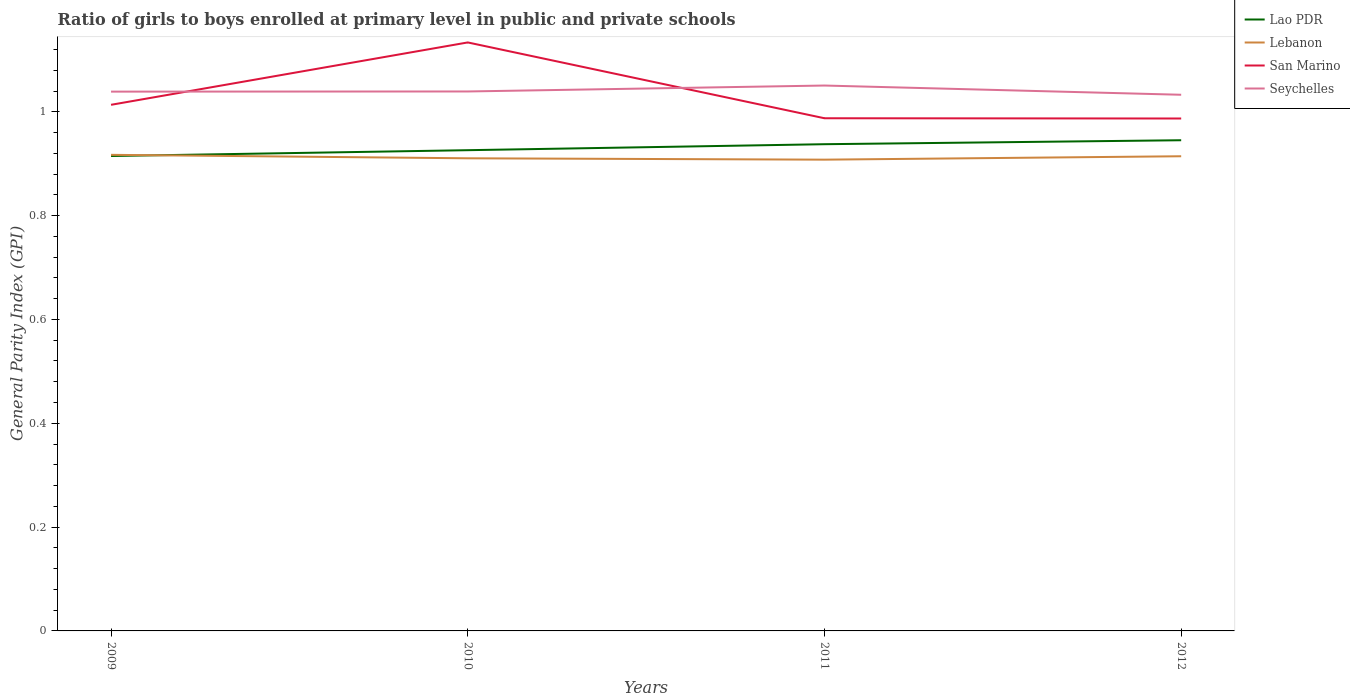Does the line corresponding to San Marino intersect with the line corresponding to Lebanon?
Offer a terse response. No. Is the number of lines equal to the number of legend labels?
Make the answer very short. Yes. Across all years, what is the maximum general parity index in San Marino?
Offer a very short reply. 0.99. In which year was the general parity index in Lao PDR maximum?
Offer a very short reply. 2009. What is the total general parity index in Lao PDR in the graph?
Keep it short and to the point. -0.01. What is the difference between the highest and the second highest general parity index in Lao PDR?
Offer a terse response. 0.03. What is the difference between the highest and the lowest general parity index in Lao PDR?
Your answer should be compact. 2. Does the graph contain any zero values?
Keep it short and to the point. No. Where does the legend appear in the graph?
Your answer should be compact. Top right. What is the title of the graph?
Provide a short and direct response. Ratio of girls to boys enrolled at primary level in public and private schools. What is the label or title of the Y-axis?
Keep it short and to the point. General Parity Index (GPI). What is the General Parity Index (GPI) of Lao PDR in 2009?
Make the answer very short. 0.91. What is the General Parity Index (GPI) of Lebanon in 2009?
Make the answer very short. 0.92. What is the General Parity Index (GPI) in San Marino in 2009?
Provide a short and direct response. 1.01. What is the General Parity Index (GPI) of Seychelles in 2009?
Give a very brief answer. 1.04. What is the General Parity Index (GPI) of Lao PDR in 2010?
Ensure brevity in your answer.  0.93. What is the General Parity Index (GPI) in Lebanon in 2010?
Offer a very short reply. 0.91. What is the General Parity Index (GPI) in San Marino in 2010?
Make the answer very short. 1.13. What is the General Parity Index (GPI) of Seychelles in 2010?
Your answer should be compact. 1.04. What is the General Parity Index (GPI) in Lao PDR in 2011?
Your answer should be very brief. 0.94. What is the General Parity Index (GPI) in Lebanon in 2011?
Provide a succinct answer. 0.91. What is the General Parity Index (GPI) in San Marino in 2011?
Provide a short and direct response. 0.99. What is the General Parity Index (GPI) in Seychelles in 2011?
Ensure brevity in your answer.  1.05. What is the General Parity Index (GPI) of Lao PDR in 2012?
Your response must be concise. 0.95. What is the General Parity Index (GPI) of Lebanon in 2012?
Offer a terse response. 0.91. What is the General Parity Index (GPI) in San Marino in 2012?
Provide a succinct answer. 0.99. What is the General Parity Index (GPI) of Seychelles in 2012?
Make the answer very short. 1.03. Across all years, what is the maximum General Parity Index (GPI) in Lao PDR?
Your answer should be compact. 0.95. Across all years, what is the maximum General Parity Index (GPI) in Lebanon?
Your response must be concise. 0.92. Across all years, what is the maximum General Parity Index (GPI) of San Marino?
Give a very brief answer. 1.13. Across all years, what is the maximum General Parity Index (GPI) in Seychelles?
Your answer should be very brief. 1.05. Across all years, what is the minimum General Parity Index (GPI) of Lao PDR?
Keep it short and to the point. 0.91. Across all years, what is the minimum General Parity Index (GPI) of Lebanon?
Offer a very short reply. 0.91. Across all years, what is the minimum General Parity Index (GPI) of San Marino?
Your answer should be compact. 0.99. Across all years, what is the minimum General Parity Index (GPI) in Seychelles?
Offer a terse response. 1.03. What is the total General Parity Index (GPI) of Lao PDR in the graph?
Keep it short and to the point. 3.72. What is the total General Parity Index (GPI) of Lebanon in the graph?
Keep it short and to the point. 3.65. What is the total General Parity Index (GPI) in San Marino in the graph?
Your answer should be compact. 4.12. What is the total General Parity Index (GPI) in Seychelles in the graph?
Your response must be concise. 4.16. What is the difference between the General Parity Index (GPI) of Lao PDR in 2009 and that in 2010?
Your answer should be very brief. -0.01. What is the difference between the General Parity Index (GPI) in Lebanon in 2009 and that in 2010?
Your answer should be very brief. 0.01. What is the difference between the General Parity Index (GPI) of San Marino in 2009 and that in 2010?
Offer a terse response. -0.12. What is the difference between the General Parity Index (GPI) of Seychelles in 2009 and that in 2010?
Give a very brief answer. -0. What is the difference between the General Parity Index (GPI) of Lao PDR in 2009 and that in 2011?
Your response must be concise. -0.02. What is the difference between the General Parity Index (GPI) of Lebanon in 2009 and that in 2011?
Ensure brevity in your answer.  0.01. What is the difference between the General Parity Index (GPI) in San Marino in 2009 and that in 2011?
Ensure brevity in your answer.  0.03. What is the difference between the General Parity Index (GPI) in Seychelles in 2009 and that in 2011?
Your answer should be very brief. -0.01. What is the difference between the General Parity Index (GPI) in Lao PDR in 2009 and that in 2012?
Keep it short and to the point. -0.03. What is the difference between the General Parity Index (GPI) in Lebanon in 2009 and that in 2012?
Ensure brevity in your answer.  0. What is the difference between the General Parity Index (GPI) in San Marino in 2009 and that in 2012?
Provide a short and direct response. 0.03. What is the difference between the General Parity Index (GPI) in Seychelles in 2009 and that in 2012?
Provide a succinct answer. 0.01. What is the difference between the General Parity Index (GPI) of Lao PDR in 2010 and that in 2011?
Keep it short and to the point. -0.01. What is the difference between the General Parity Index (GPI) of Lebanon in 2010 and that in 2011?
Ensure brevity in your answer.  0. What is the difference between the General Parity Index (GPI) of San Marino in 2010 and that in 2011?
Offer a terse response. 0.15. What is the difference between the General Parity Index (GPI) in Seychelles in 2010 and that in 2011?
Offer a very short reply. -0.01. What is the difference between the General Parity Index (GPI) of Lao PDR in 2010 and that in 2012?
Your response must be concise. -0.02. What is the difference between the General Parity Index (GPI) of Lebanon in 2010 and that in 2012?
Give a very brief answer. -0. What is the difference between the General Parity Index (GPI) in San Marino in 2010 and that in 2012?
Give a very brief answer. 0.15. What is the difference between the General Parity Index (GPI) in Seychelles in 2010 and that in 2012?
Ensure brevity in your answer.  0.01. What is the difference between the General Parity Index (GPI) in Lao PDR in 2011 and that in 2012?
Provide a short and direct response. -0.01. What is the difference between the General Parity Index (GPI) in Lebanon in 2011 and that in 2012?
Make the answer very short. -0.01. What is the difference between the General Parity Index (GPI) in San Marino in 2011 and that in 2012?
Offer a very short reply. 0. What is the difference between the General Parity Index (GPI) in Seychelles in 2011 and that in 2012?
Keep it short and to the point. 0.02. What is the difference between the General Parity Index (GPI) of Lao PDR in 2009 and the General Parity Index (GPI) of Lebanon in 2010?
Your answer should be very brief. 0. What is the difference between the General Parity Index (GPI) of Lao PDR in 2009 and the General Parity Index (GPI) of San Marino in 2010?
Ensure brevity in your answer.  -0.22. What is the difference between the General Parity Index (GPI) of Lao PDR in 2009 and the General Parity Index (GPI) of Seychelles in 2010?
Ensure brevity in your answer.  -0.12. What is the difference between the General Parity Index (GPI) in Lebanon in 2009 and the General Parity Index (GPI) in San Marino in 2010?
Your response must be concise. -0.22. What is the difference between the General Parity Index (GPI) in Lebanon in 2009 and the General Parity Index (GPI) in Seychelles in 2010?
Ensure brevity in your answer.  -0.12. What is the difference between the General Parity Index (GPI) in San Marino in 2009 and the General Parity Index (GPI) in Seychelles in 2010?
Provide a short and direct response. -0.03. What is the difference between the General Parity Index (GPI) of Lao PDR in 2009 and the General Parity Index (GPI) of Lebanon in 2011?
Provide a short and direct response. 0.01. What is the difference between the General Parity Index (GPI) in Lao PDR in 2009 and the General Parity Index (GPI) in San Marino in 2011?
Your answer should be very brief. -0.07. What is the difference between the General Parity Index (GPI) of Lao PDR in 2009 and the General Parity Index (GPI) of Seychelles in 2011?
Offer a very short reply. -0.14. What is the difference between the General Parity Index (GPI) of Lebanon in 2009 and the General Parity Index (GPI) of San Marino in 2011?
Your response must be concise. -0.07. What is the difference between the General Parity Index (GPI) of Lebanon in 2009 and the General Parity Index (GPI) of Seychelles in 2011?
Make the answer very short. -0.13. What is the difference between the General Parity Index (GPI) in San Marino in 2009 and the General Parity Index (GPI) in Seychelles in 2011?
Give a very brief answer. -0.04. What is the difference between the General Parity Index (GPI) in Lao PDR in 2009 and the General Parity Index (GPI) in Lebanon in 2012?
Offer a very short reply. 0. What is the difference between the General Parity Index (GPI) in Lao PDR in 2009 and the General Parity Index (GPI) in San Marino in 2012?
Give a very brief answer. -0.07. What is the difference between the General Parity Index (GPI) in Lao PDR in 2009 and the General Parity Index (GPI) in Seychelles in 2012?
Your response must be concise. -0.12. What is the difference between the General Parity Index (GPI) of Lebanon in 2009 and the General Parity Index (GPI) of San Marino in 2012?
Provide a short and direct response. -0.07. What is the difference between the General Parity Index (GPI) of Lebanon in 2009 and the General Parity Index (GPI) of Seychelles in 2012?
Offer a very short reply. -0.12. What is the difference between the General Parity Index (GPI) in San Marino in 2009 and the General Parity Index (GPI) in Seychelles in 2012?
Your answer should be very brief. -0.02. What is the difference between the General Parity Index (GPI) in Lao PDR in 2010 and the General Parity Index (GPI) in Lebanon in 2011?
Make the answer very short. 0.02. What is the difference between the General Parity Index (GPI) of Lao PDR in 2010 and the General Parity Index (GPI) of San Marino in 2011?
Give a very brief answer. -0.06. What is the difference between the General Parity Index (GPI) of Lao PDR in 2010 and the General Parity Index (GPI) of Seychelles in 2011?
Your answer should be compact. -0.12. What is the difference between the General Parity Index (GPI) in Lebanon in 2010 and the General Parity Index (GPI) in San Marino in 2011?
Provide a short and direct response. -0.08. What is the difference between the General Parity Index (GPI) of Lebanon in 2010 and the General Parity Index (GPI) of Seychelles in 2011?
Offer a terse response. -0.14. What is the difference between the General Parity Index (GPI) in San Marino in 2010 and the General Parity Index (GPI) in Seychelles in 2011?
Your answer should be compact. 0.08. What is the difference between the General Parity Index (GPI) in Lao PDR in 2010 and the General Parity Index (GPI) in Lebanon in 2012?
Offer a terse response. 0.01. What is the difference between the General Parity Index (GPI) of Lao PDR in 2010 and the General Parity Index (GPI) of San Marino in 2012?
Your answer should be compact. -0.06. What is the difference between the General Parity Index (GPI) of Lao PDR in 2010 and the General Parity Index (GPI) of Seychelles in 2012?
Your answer should be compact. -0.11. What is the difference between the General Parity Index (GPI) of Lebanon in 2010 and the General Parity Index (GPI) of San Marino in 2012?
Your response must be concise. -0.08. What is the difference between the General Parity Index (GPI) in Lebanon in 2010 and the General Parity Index (GPI) in Seychelles in 2012?
Keep it short and to the point. -0.12. What is the difference between the General Parity Index (GPI) of San Marino in 2010 and the General Parity Index (GPI) of Seychelles in 2012?
Your answer should be compact. 0.1. What is the difference between the General Parity Index (GPI) in Lao PDR in 2011 and the General Parity Index (GPI) in Lebanon in 2012?
Your answer should be compact. 0.02. What is the difference between the General Parity Index (GPI) of Lao PDR in 2011 and the General Parity Index (GPI) of San Marino in 2012?
Your answer should be compact. -0.05. What is the difference between the General Parity Index (GPI) in Lao PDR in 2011 and the General Parity Index (GPI) in Seychelles in 2012?
Provide a succinct answer. -0.1. What is the difference between the General Parity Index (GPI) of Lebanon in 2011 and the General Parity Index (GPI) of San Marino in 2012?
Make the answer very short. -0.08. What is the difference between the General Parity Index (GPI) of Lebanon in 2011 and the General Parity Index (GPI) of Seychelles in 2012?
Ensure brevity in your answer.  -0.12. What is the difference between the General Parity Index (GPI) in San Marino in 2011 and the General Parity Index (GPI) in Seychelles in 2012?
Make the answer very short. -0.05. What is the average General Parity Index (GPI) of Lao PDR per year?
Your answer should be very brief. 0.93. What is the average General Parity Index (GPI) in Lebanon per year?
Your answer should be compact. 0.91. What is the average General Parity Index (GPI) of San Marino per year?
Ensure brevity in your answer.  1.03. What is the average General Parity Index (GPI) in Seychelles per year?
Provide a short and direct response. 1.04. In the year 2009, what is the difference between the General Parity Index (GPI) of Lao PDR and General Parity Index (GPI) of Lebanon?
Give a very brief answer. -0. In the year 2009, what is the difference between the General Parity Index (GPI) in Lao PDR and General Parity Index (GPI) in San Marino?
Your response must be concise. -0.1. In the year 2009, what is the difference between the General Parity Index (GPI) of Lao PDR and General Parity Index (GPI) of Seychelles?
Keep it short and to the point. -0.12. In the year 2009, what is the difference between the General Parity Index (GPI) in Lebanon and General Parity Index (GPI) in San Marino?
Provide a short and direct response. -0.1. In the year 2009, what is the difference between the General Parity Index (GPI) in Lebanon and General Parity Index (GPI) in Seychelles?
Offer a very short reply. -0.12. In the year 2009, what is the difference between the General Parity Index (GPI) of San Marino and General Parity Index (GPI) of Seychelles?
Keep it short and to the point. -0.03. In the year 2010, what is the difference between the General Parity Index (GPI) of Lao PDR and General Parity Index (GPI) of Lebanon?
Offer a terse response. 0.02. In the year 2010, what is the difference between the General Parity Index (GPI) of Lao PDR and General Parity Index (GPI) of San Marino?
Offer a very short reply. -0.21. In the year 2010, what is the difference between the General Parity Index (GPI) in Lao PDR and General Parity Index (GPI) in Seychelles?
Your response must be concise. -0.11. In the year 2010, what is the difference between the General Parity Index (GPI) of Lebanon and General Parity Index (GPI) of San Marino?
Your response must be concise. -0.22. In the year 2010, what is the difference between the General Parity Index (GPI) in Lebanon and General Parity Index (GPI) in Seychelles?
Provide a succinct answer. -0.13. In the year 2010, what is the difference between the General Parity Index (GPI) in San Marino and General Parity Index (GPI) in Seychelles?
Give a very brief answer. 0.09. In the year 2011, what is the difference between the General Parity Index (GPI) in Lao PDR and General Parity Index (GPI) in Lebanon?
Give a very brief answer. 0.03. In the year 2011, what is the difference between the General Parity Index (GPI) in Lao PDR and General Parity Index (GPI) in San Marino?
Your response must be concise. -0.05. In the year 2011, what is the difference between the General Parity Index (GPI) in Lao PDR and General Parity Index (GPI) in Seychelles?
Your answer should be compact. -0.11. In the year 2011, what is the difference between the General Parity Index (GPI) of Lebanon and General Parity Index (GPI) of San Marino?
Provide a short and direct response. -0.08. In the year 2011, what is the difference between the General Parity Index (GPI) of Lebanon and General Parity Index (GPI) of Seychelles?
Give a very brief answer. -0.14. In the year 2011, what is the difference between the General Parity Index (GPI) of San Marino and General Parity Index (GPI) of Seychelles?
Offer a very short reply. -0.06. In the year 2012, what is the difference between the General Parity Index (GPI) in Lao PDR and General Parity Index (GPI) in Lebanon?
Offer a very short reply. 0.03. In the year 2012, what is the difference between the General Parity Index (GPI) of Lao PDR and General Parity Index (GPI) of San Marino?
Offer a very short reply. -0.04. In the year 2012, what is the difference between the General Parity Index (GPI) of Lao PDR and General Parity Index (GPI) of Seychelles?
Give a very brief answer. -0.09. In the year 2012, what is the difference between the General Parity Index (GPI) in Lebanon and General Parity Index (GPI) in San Marino?
Offer a terse response. -0.07. In the year 2012, what is the difference between the General Parity Index (GPI) of Lebanon and General Parity Index (GPI) of Seychelles?
Make the answer very short. -0.12. In the year 2012, what is the difference between the General Parity Index (GPI) of San Marino and General Parity Index (GPI) of Seychelles?
Offer a terse response. -0.05. What is the ratio of the General Parity Index (GPI) of Lao PDR in 2009 to that in 2010?
Provide a short and direct response. 0.99. What is the ratio of the General Parity Index (GPI) of Lebanon in 2009 to that in 2010?
Your answer should be very brief. 1.01. What is the ratio of the General Parity Index (GPI) in San Marino in 2009 to that in 2010?
Your answer should be very brief. 0.89. What is the ratio of the General Parity Index (GPI) in Lao PDR in 2009 to that in 2011?
Ensure brevity in your answer.  0.98. What is the ratio of the General Parity Index (GPI) in Lebanon in 2009 to that in 2011?
Your response must be concise. 1.01. What is the ratio of the General Parity Index (GPI) of San Marino in 2009 to that in 2011?
Provide a succinct answer. 1.03. What is the ratio of the General Parity Index (GPI) of Lao PDR in 2009 to that in 2012?
Provide a succinct answer. 0.97. What is the ratio of the General Parity Index (GPI) of San Marino in 2009 to that in 2012?
Your answer should be compact. 1.03. What is the ratio of the General Parity Index (GPI) of Seychelles in 2009 to that in 2012?
Offer a very short reply. 1.01. What is the ratio of the General Parity Index (GPI) of Lebanon in 2010 to that in 2011?
Your answer should be compact. 1. What is the ratio of the General Parity Index (GPI) in San Marino in 2010 to that in 2011?
Your response must be concise. 1.15. What is the ratio of the General Parity Index (GPI) in Seychelles in 2010 to that in 2011?
Your answer should be compact. 0.99. What is the ratio of the General Parity Index (GPI) of Lao PDR in 2010 to that in 2012?
Offer a very short reply. 0.98. What is the ratio of the General Parity Index (GPI) of San Marino in 2010 to that in 2012?
Your response must be concise. 1.15. What is the ratio of the General Parity Index (GPI) in Lao PDR in 2011 to that in 2012?
Make the answer very short. 0.99. What is the ratio of the General Parity Index (GPI) in San Marino in 2011 to that in 2012?
Your answer should be very brief. 1. What is the ratio of the General Parity Index (GPI) of Seychelles in 2011 to that in 2012?
Provide a succinct answer. 1.02. What is the difference between the highest and the second highest General Parity Index (GPI) of Lao PDR?
Give a very brief answer. 0.01. What is the difference between the highest and the second highest General Parity Index (GPI) in Lebanon?
Offer a terse response. 0. What is the difference between the highest and the second highest General Parity Index (GPI) of San Marino?
Give a very brief answer. 0.12. What is the difference between the highest and the second highest General Parity Index (GPI) in Seychelles?
Ensure brevity in your answer.  0.01. What is the difference between the highest and the lowest General Parity Index (GPI) in Lao PDR?
Give a very brief answer. 0.03. What is the difference between the highest and the lowest General Parity Index (GPI) in Lebanon?
Offer a very short reply. 0.01. What is the difference between the highest and the lowest General Parity Index (GPI) in San Marino?
Offer a terse response. 0.15. What is the difference between the highest and the lowest General Parity Index (GPI) of Seychelles?
Keep it short and to the point. 0.02. 